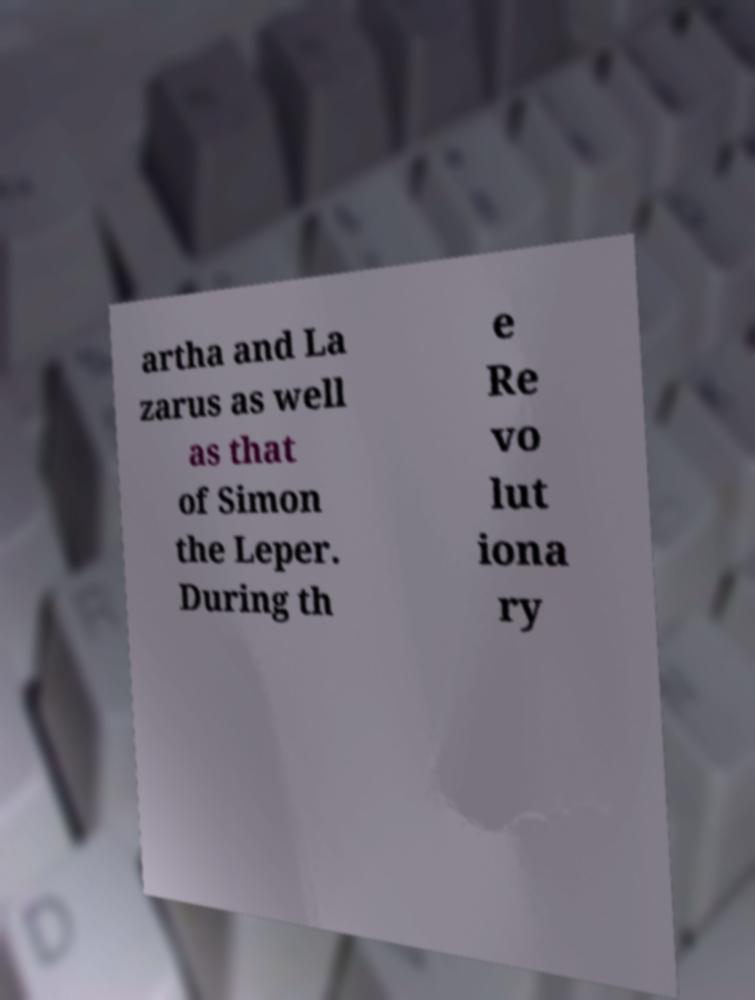What messages or text are displayed in this image? I need them in a readable, typed format. artha and La zarus as well as that of Simon the Leper. During th e Re vo lut iona ry 